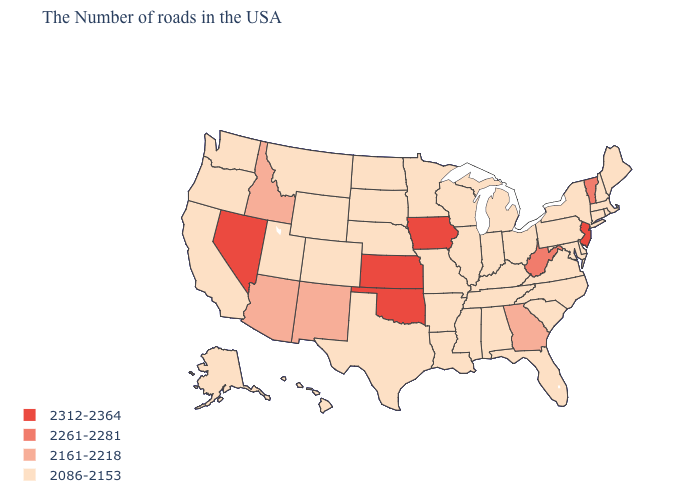Name the states that have a value in the range 2161-2218?
Be succinct. Georgia, New Mexico, Arizona, Idaho. Does Connecticut have the lowest value in the USA?
Quick response, please. Yes. Among the states that border Alabama , which have the highest value?
Be succinct. Georgia. Name the states that have a value in the range 2086-2153?
Write a very short answer. Maine, Massachusetts, Rhode Island, New Hampshire, Connecticut, New York, Delaware, Maryland, Pennsylvania, Virginia, North Carolina, South Carolina, Ohio, Florida, Michigan, Kentucky, Indiana, Alabama, Tennessee, Wisconsin, Illinois, Mississippi, Louisiana, Missouri, Arkansas, Minnesota, Nebraska, Texas, South Dakota, North Dakota, Wyoming, Colorado, Utah, Montana, California, Washington, Oregon, Alaska, Hawaii. How many symbols are there in the legend?
Keep it brief. 4. Name the states that have a value in the range 2312-2364?
Concise answer only. New Jersey, Iowa, Kansas, Oklahoma, Nevada. What is the value of California?
Answer briefly. 2086-2153. Name the states that have a value in the range 2261-2281?
Quick response, please. Vermont, West Virginia. What is the value of New Mexico?
Answer briefly. 2161-2218. What is the lowest value in states that border Ohio?
Be succinct. 2086-2153. Does Maryland have the lowest value in the South?
Keep it brief. Yes. What is the lowest value in the USA?
Be succinct. 2086-2153. Does South Dakota have a higher value than North Dakota?
Quick response, please. No. What is the value of Tennessee?
Short answer required. 2086-2153. 